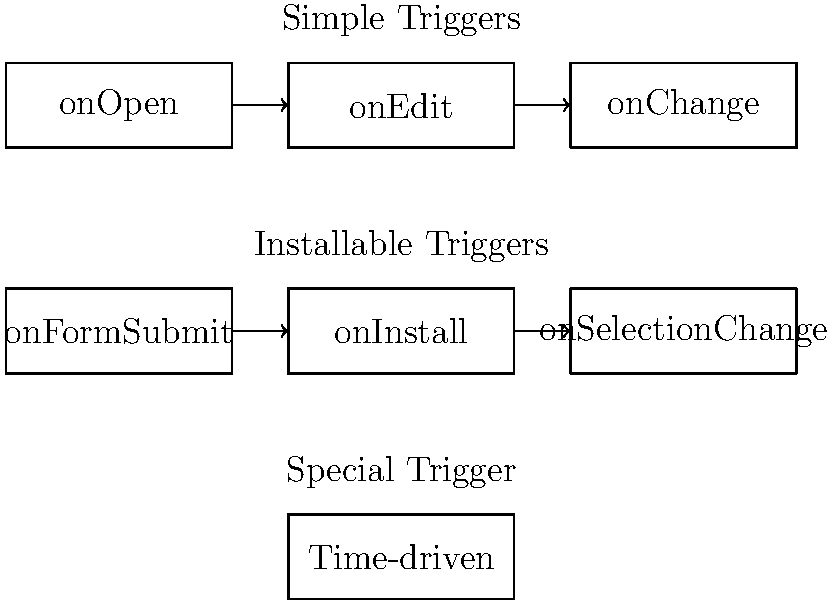Based on the diagram illustrating Google Apps Script triggers, which type of trigger would execute first if an edit is made to a spreadsheet, an form is submitted, and a time-driven trigger is scheduled to run at the same moment? To determine which trigger would execute first, we need to understand the hierarchy and execution order of Google Apps Script triggers:

1. Simple triggers (top row in the diagram) always execute before installable triggers.
2. Among simple triggers, they execute in this order: onOpen, onEdit, onChange.
3. Installable triggers (middle row) execute after simple triggers, but their exact order can be configured.
4. Time-driven triggers (bottom row) are special and execute independently of other triggers.

Given the scenario:
- An edit is made to a spreadsheet, which would trigger onEdit (a simple trigger).
- A form is submitted, which would trigger onFormSubmit (an installable trigger).
- A time-driven trigger is scheduled to run at the same moment.

The execution order would be:
1. onEdit (simple trigger) executes first due to the spreadsheet edit.
2. onFormSubmit (installable trigger) executes next due to the form submission.
3. The time-driven trigger executes independently and its exact timing relative to the other triggers is not guaranteed.

Therefore, the trigger that would execute first in this scenario is the onEdit trigger.
Answer: onEdit 